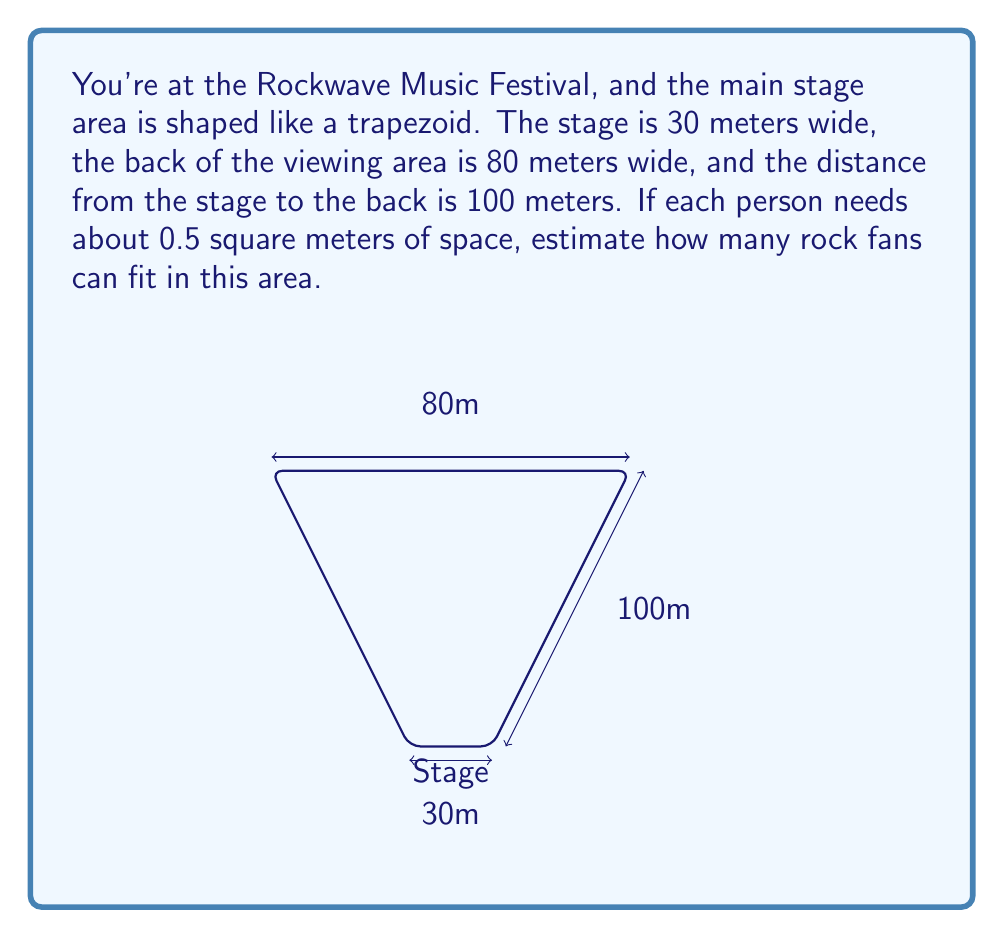Can you solve this math problem? Let's approach this step-by-step:

1) First, we need to calculate the area of the trapezoid. The formula for the area of a trapezoid is:

   $$A = \frac{1}{2}(a+b)h$$

   where $a$ and $b$ are the parallel sides and $h$ is the height.

2) In this case:
   $a = 30$ m (stage width)
   $b = 80$ m (back width)
   $h = 100$ m (depth)

3) Plugging these into the formula:

   $$A = \frac{1}{2}(30+80) \times 100 = \frac{1}{2} \times 110 \times 100 = 5500 \text{ m}^2$$

4) Now that we have the total area, we need to divide it by the space each person needs (0.5 m²):

   $$\text{Number of people} = \frac{\text{Total Area}}{\text{Area per person}} = \frac{5500}{0.5} = 11000$$

5) However, this is a theoretical maximum. In reality, there would be some space needed for walkways, equipment, etc. It's common to reduce the estimate by about 10-15% for a more realistic number.

   $$11000 \times 0.85 \approx 9350$$

Therefore, a reasonable estimate would be about 9,350 rock fans.
Answer: Approximately 9,350 people 